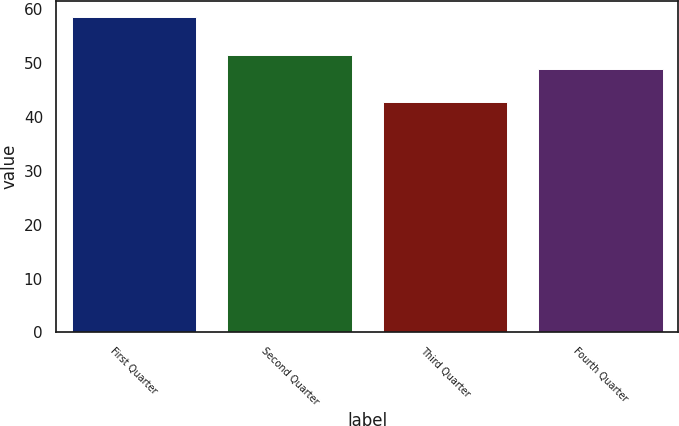Convert chart to OTSL. <chart><loc_0><loc_0><loc_500><loc_500><bar_chart><fcel>First Quarter<fcel>Second Quarter<fcel>Third Quarter<fcel>Fourth Quarter<nl><fcel>58.64<fcel>51.58<fcel>42.8<fcel>48.98<nl></chart> 